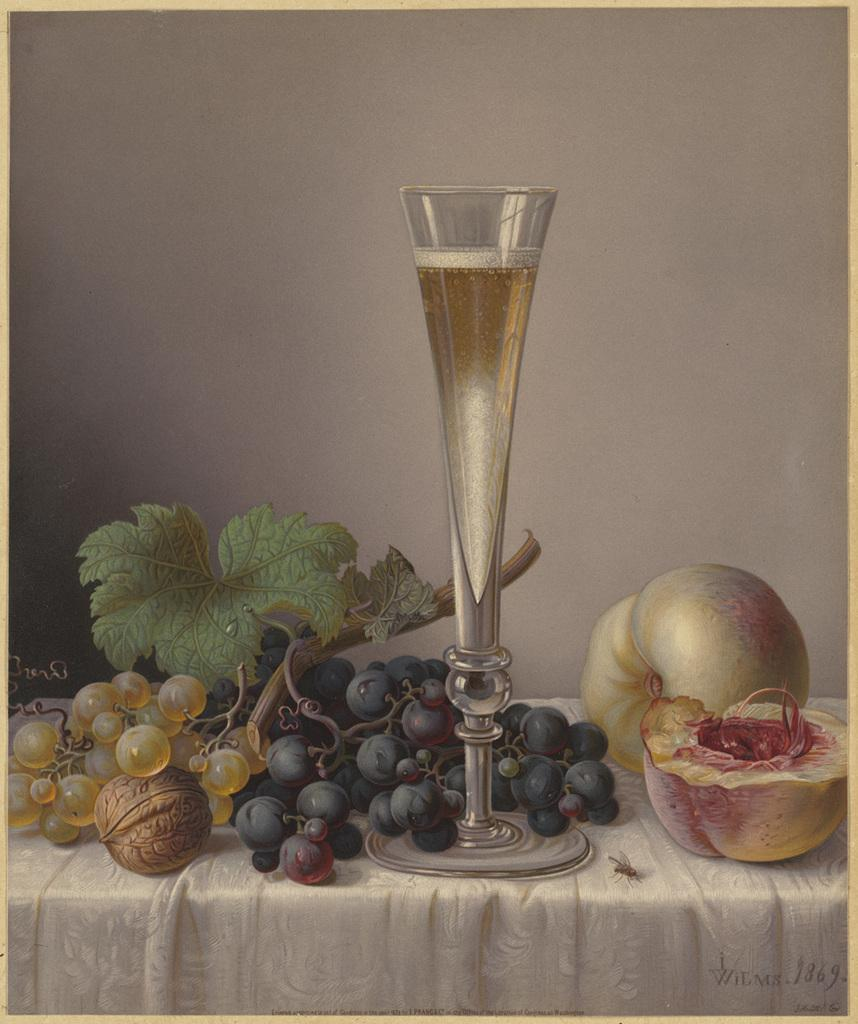What type of fruit is in the foreground of the image? There is a bunch of grapes, a walnut, and a pumpkin fruit in the foreground of the image. What object is on a table in the foreground of the image? There is a glass on a table in the foreground of the image. What can be seen in the background of the image? There is a wall visible in the background of the image. How is the image presented? The image appears to be a photo frame. What type of skin condition can be seen on the pumpkin fruit in the image? There is no skin condition visible on the pumpkin fruit in the image, as it is a fruit and not a living organism with skin. 